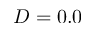<formula> <loc_0><loc_0><loc_500><loc_500>D = 0 . 0</formula> 